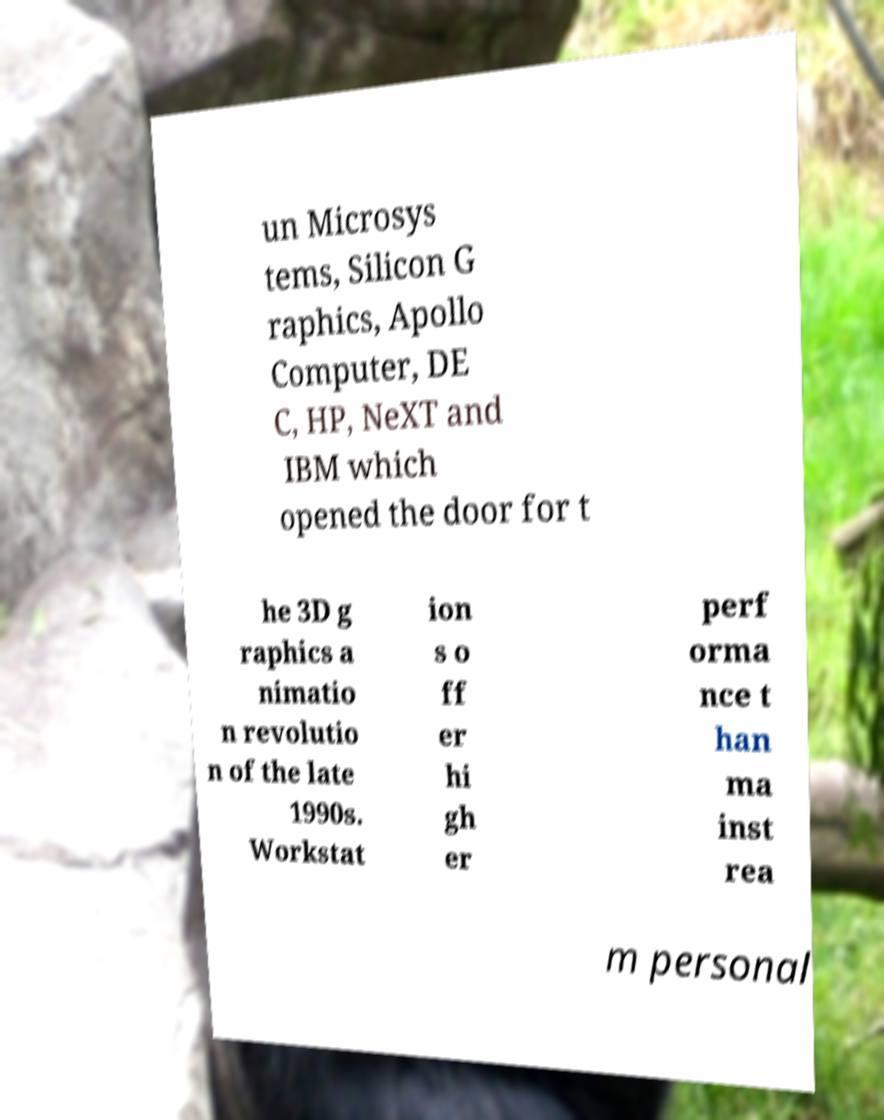Could you extract and type out the text from this image? un Microsys tems, Silicon G raphics, Apollo Computer, DE C, HP, NeXT and IBM which opened the door for t he 3D g raphics a nimatio n revolutio n of the late 1990s. Workstat ion s o ff er hi gh er perf orma nce t han ma inst rea m personal 